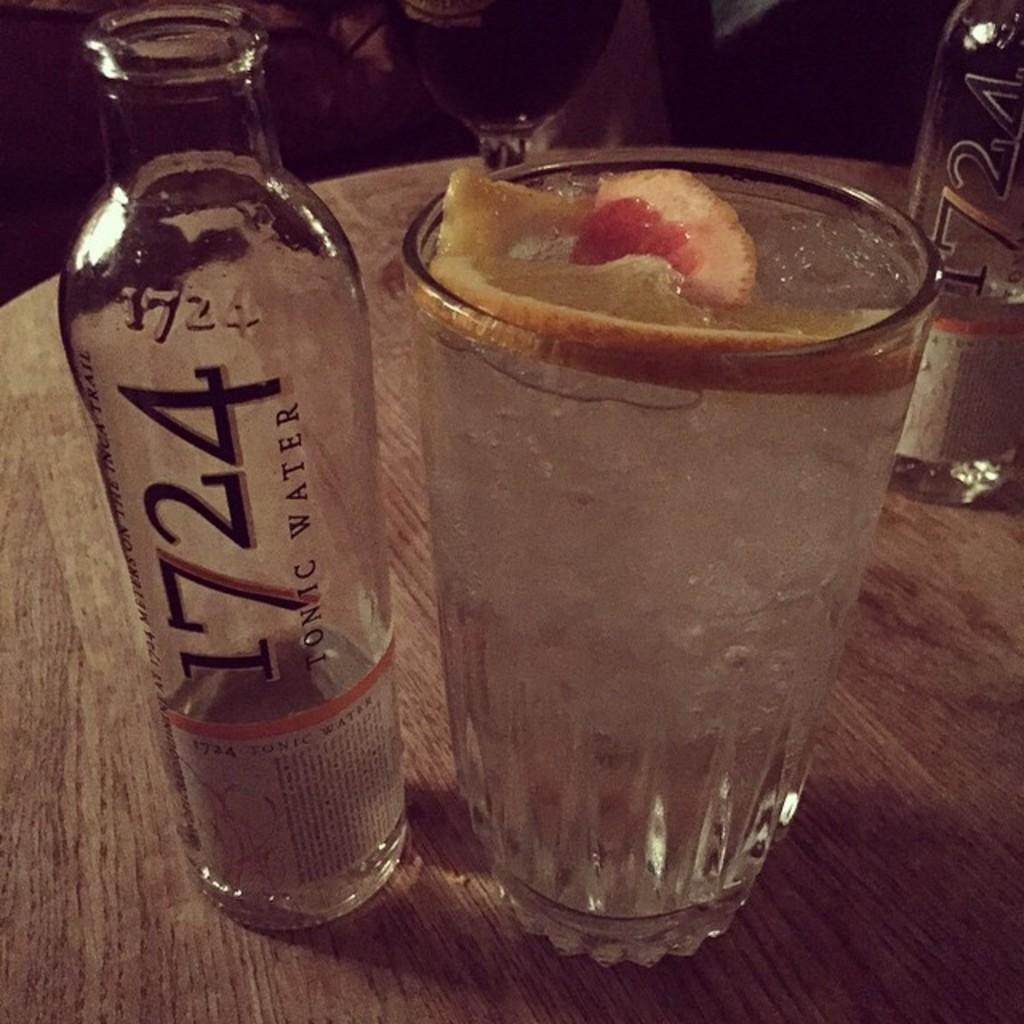<image>
Relay a brief, clear account of the picture shown. A bottle of 1724 tunic water sits on a table 